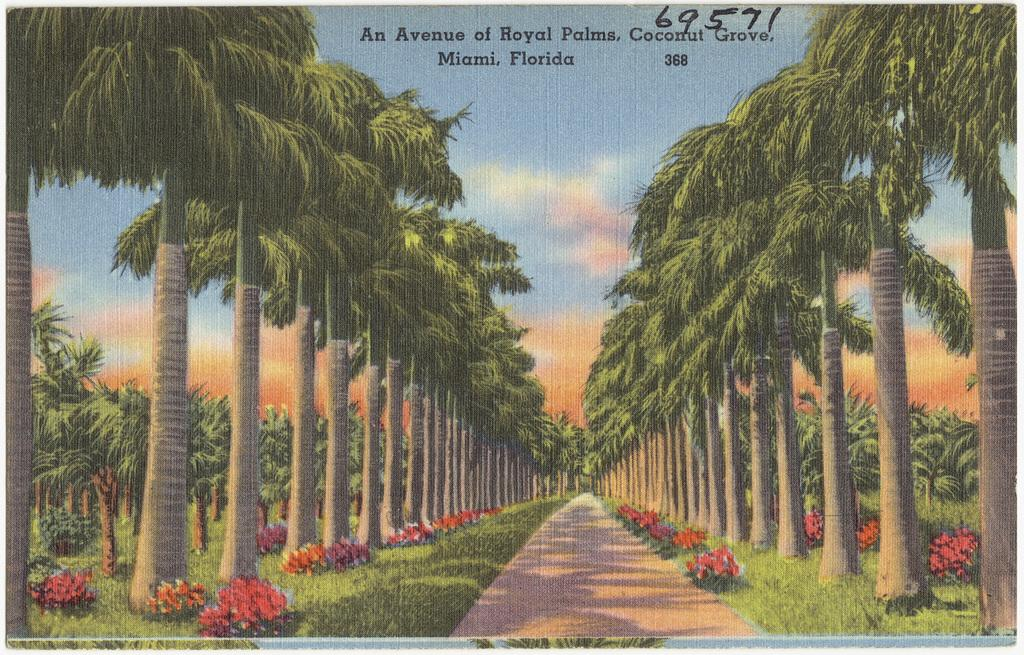What type of image is being described? The image is a portrait. What natural elements can be seen in the portrait? There are trees, flower plants, and grass in the image. Is there any indication of a path or walkway in the portrait? Yes, there is a path between the trees in the image. What type of jeans is the person wearing in the portrait? There is no person present in the portrait, as it is a landscape featuring trees, flower plants, grass, and a path. 